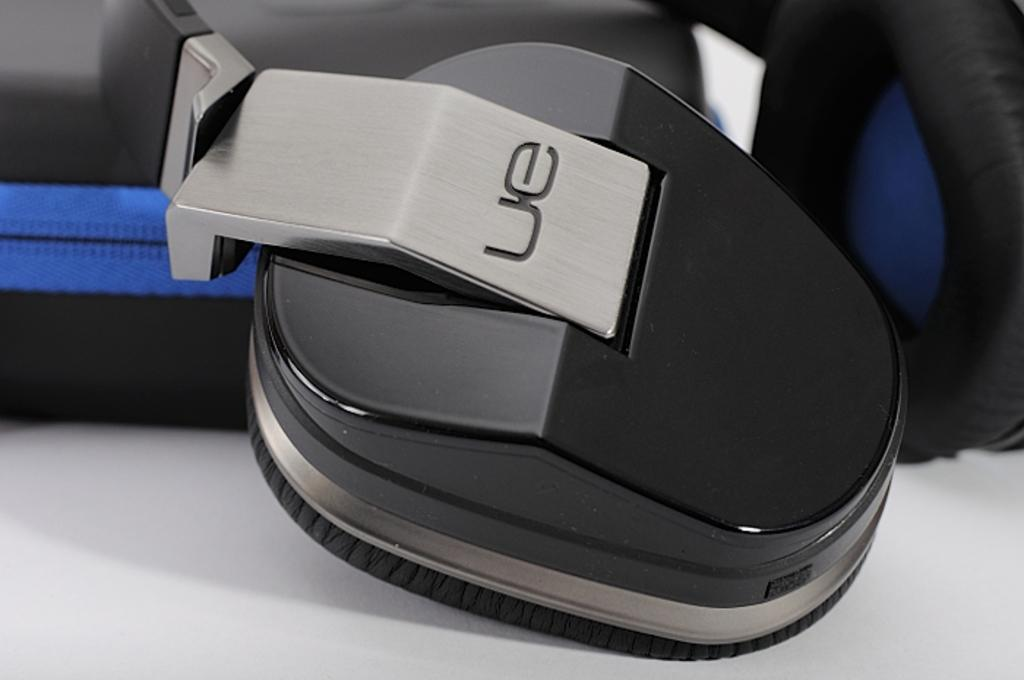What type of device is visible in the image? There is a headset in the image. What color is the headset? The headset is black in color. Where is the throne located in the image? There is no throne present in the image. What type of scene is depicted in the image? The image does not depict a scene; it only shows a black headset. 